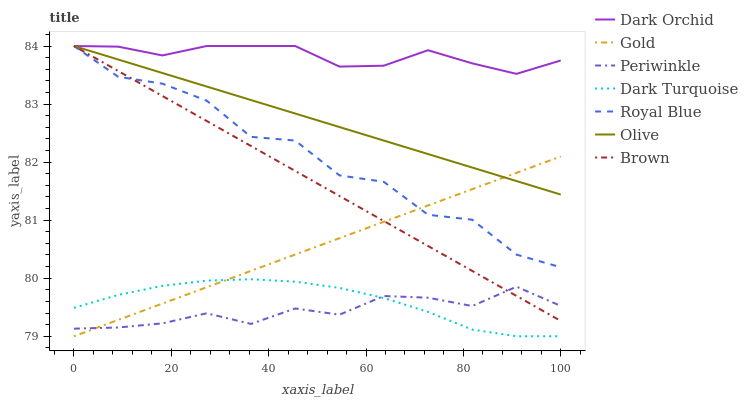Does Gold have the minimum area under the curve?
Answer yes or no. No. Does Gold have the maximum area under the curve?
Answer yes or no. No. Is Gold the smoothest?
Answer yes or no. No. Is Gold the roughest?
Answer yes or no. No. Does Dark Orchid have the lowest value?
Answer yes or no. No. Does Gold have the highest value?
Answer yes or no. No. Is Dark Turquoise less than Royal Blue?
Answer yes or no. Yes. Is Dark Orchid greater than Dark Turquoise?
Answer yes or no. Yes. Does Dark Turquoise intersect Royal Blue?
Answer yes or no. No. 